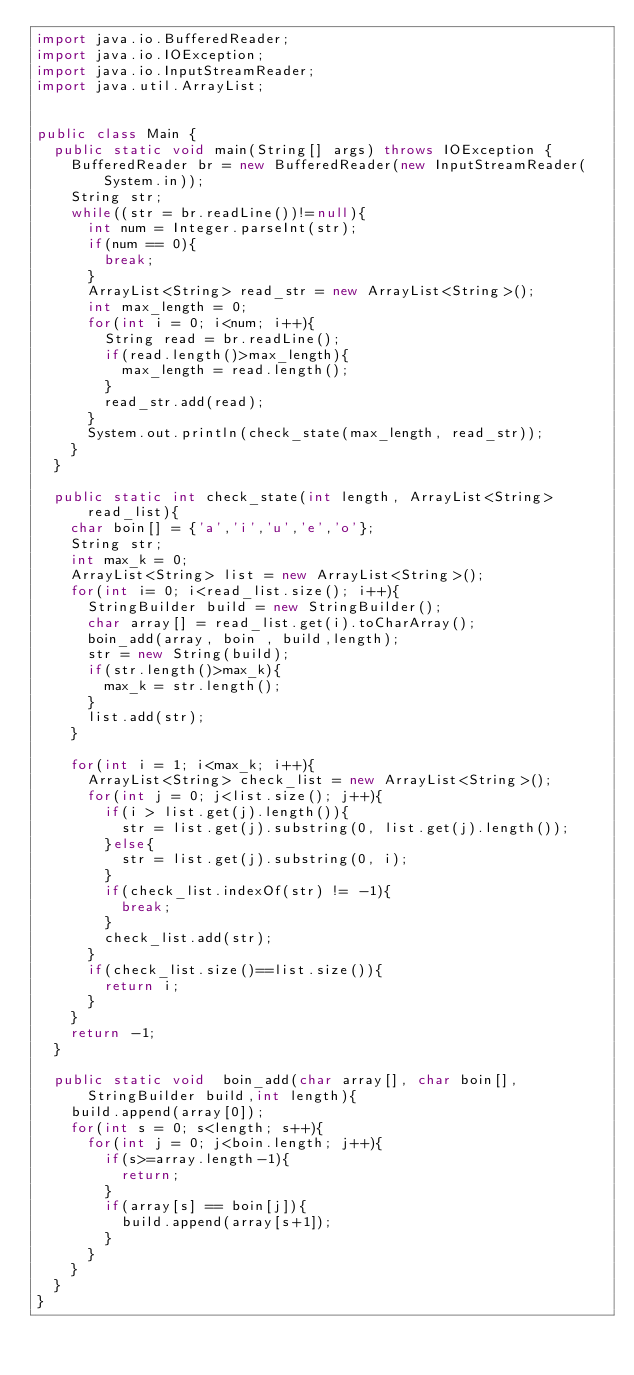Convert code to text. <code><loc_0><loc_0><loc_500><loc_500><_Java_>import java.io.BufferedReader;
import java.io.IOException;
import java.io.InputStreamReader;
import java.util.ArrayList;


public class Main {
	public static void main(String[] args) throws IOException {
		BufferedReader br = new BufferedReader(new InputStreamReader(System.in));
		String str;
		while((str = br.readLine())!=null){
			int num = Integer.parseInt(str);
			if(num == 0){
				break;
			}
			ArrayList<String> read_str = new ArrayList<String>();
			int max_length = 0;
			for(int i = 0; i<num; i++){
				String read = br.readLine();
				if(read.length()>max_length){
					max_length = read.length();
				}
				read_str.add(read);
			}
			System.out.println(check_state(max_length, read_str));
		}
	}

	public static int check_state(int length, ArrayList<String> read_list){
		char boin[] = {'a','i','u','e','o'};
		String str;
		int max_k = 0;
		ArrayList<String> list = new ArrayList<String>();
		for(int i= 0; i<read_list.size(); i++){
			StringBuilder build = new StringBuilder();
			char array[] = read_list.get(i).toCharArray();
			boin_add(array, boin , build,length);
			str = new String(build);
			if(str.length()>max_k){
				max_k = str.length();
			}
			list.add(str);
		}

		for(int i = 1; i<max_k; i++){
			ArrayList<String> check_list = new ArrayList<String>();
			for(int j = 0; j<list.size(); j++){
				if(i > list.get(j).length()){
					str = list.get(j).substring(0, list.get(j).length());
				}else{
					str = list.get(j).substring(0, i);
				}
				if(check_list.indexOf(str) != -1){
					break;
				}
				check_list.add(str);
			}
			if(check_list.size()==list.size()){
				return i;
			}
		}
		return -1;
	}

	public static void  boin_add(char array[], char boin[], StringBuilder build,int length){
		build.append(array[0]);
		for(int s = 0; s<length; s++){
			for(int j = 0; j<boin.length; j++){
				if(s>=array.length-1){
					return;
				}
				if(array[s] == boin[j]){
					build.append(array[s+1]);
				}
			}
		}
	}
}</code> 